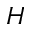Convert formula to latex. <formula><loc_0><loc_0><loc_500><loc_500>H</formula> 